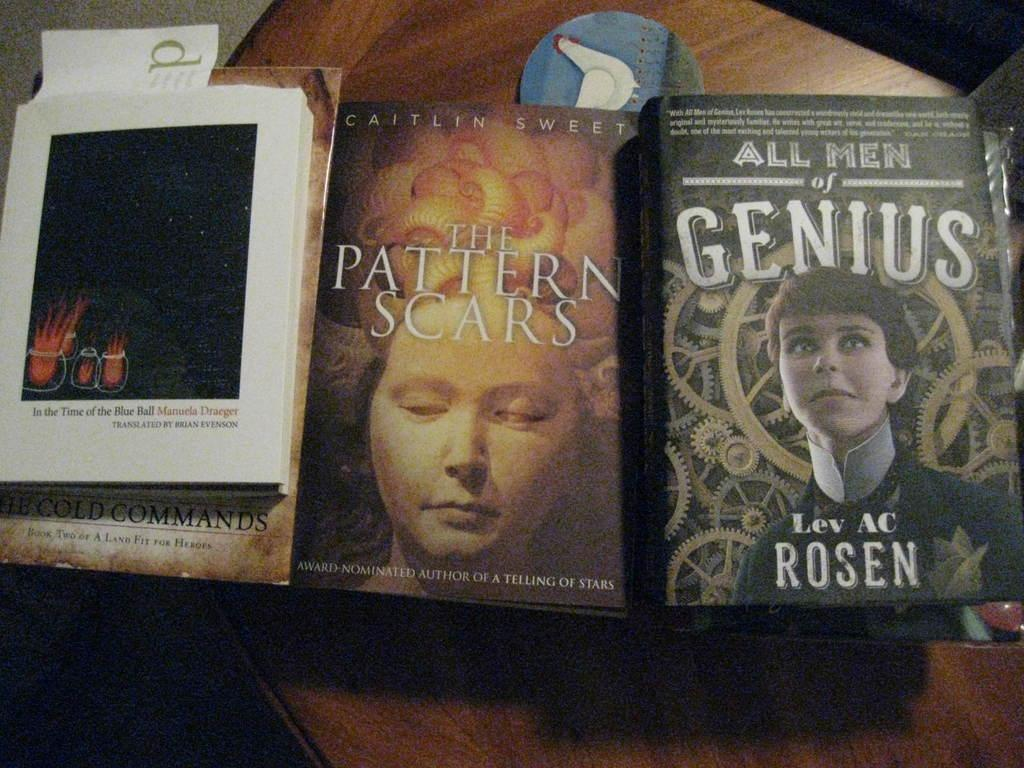What type of objects can be seen in the image? There are books, paper, and a badge in the image. Where are these objects placed? The books, paper, and badge are placed on a wooden table. What material is the table made of? The table is made of wood. What shape is the hydrant in the image? There is no hydrant present in the image. How does the twist in the image affect the arrangement of the objects? There is no twist mentioned in the image, and the objects are simply placed on the wooden table. 